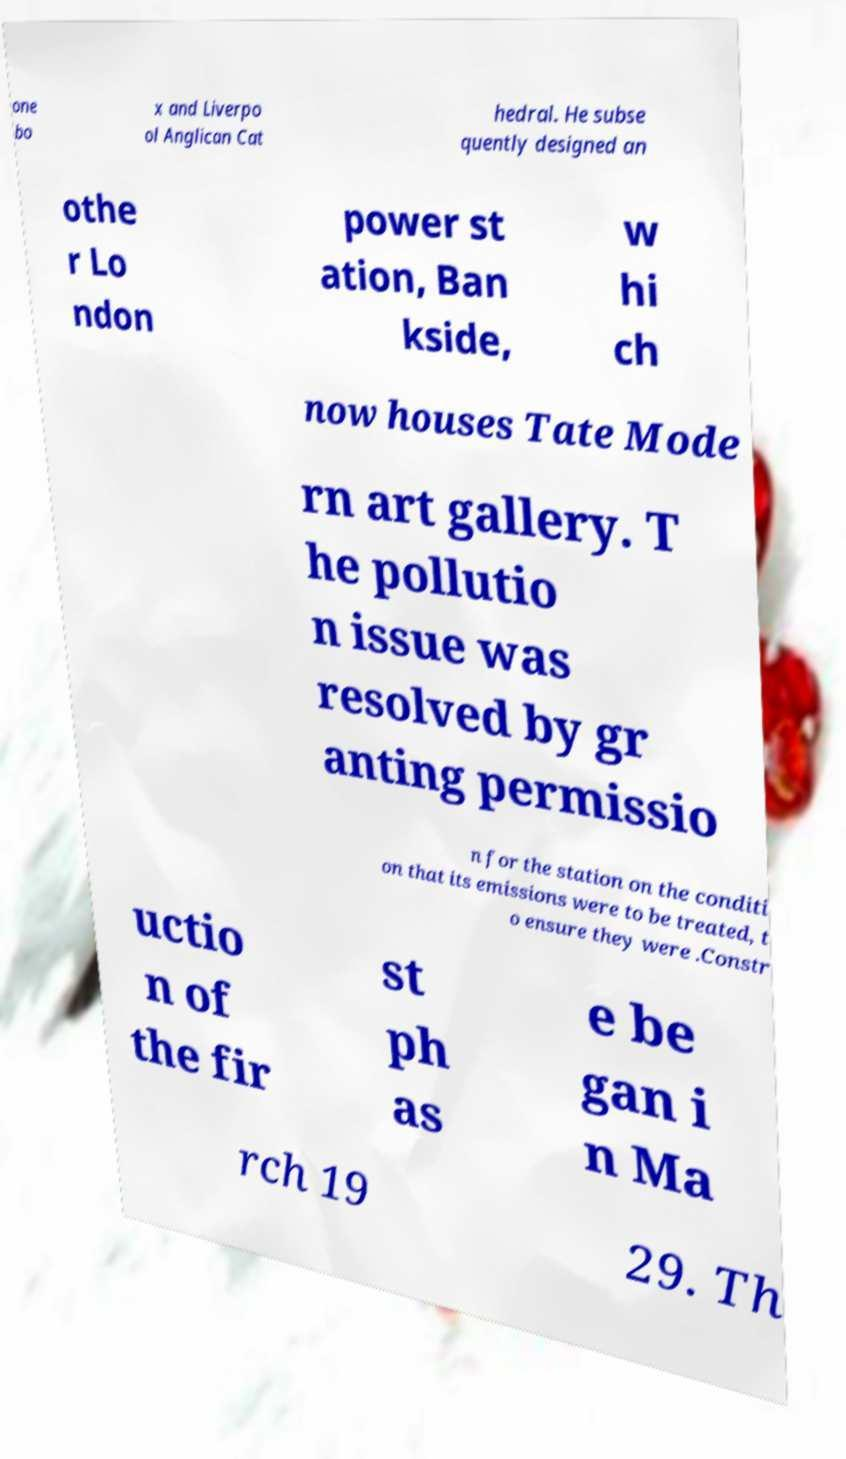Can you read and provide the text displayed in the image?This photo seems to have some interesting text. Can you extract and type it out for me? one bo x and Liverpo ol Anglican Cat hedral. He subse quently designed an othe r Lo ndon power st ation, Ban kside, w hi ch now houses Tate Mode rn art gallery. T he pollutio n issue was resolved by gr anting permissio n for the station on the conditi on that its emissions were to be treated, t o ensure they were .Constr uctio n of the fir st ph as e be gan i n Ma rch 19 29. Th 